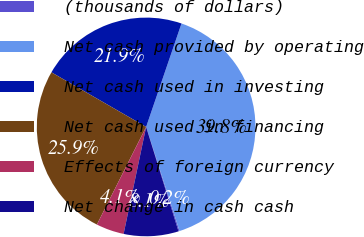Convert chart. <chart><loc_0><loc_0><loc_500><loc_500><pie_chart><fcel>(thousands of dollars)<fcel>Net cash provided by operating<fcel>Net cash used in investing<fcel>Net cash used in financing<fcel>Effects of foreign currency<fcel>Net change in cash cash<nl><fcel>0.16%<fcel>39.81%<fcel>21.92%<fcel>25.89%<fcel>4.13%<fcel>8.09%<nl></chart> 